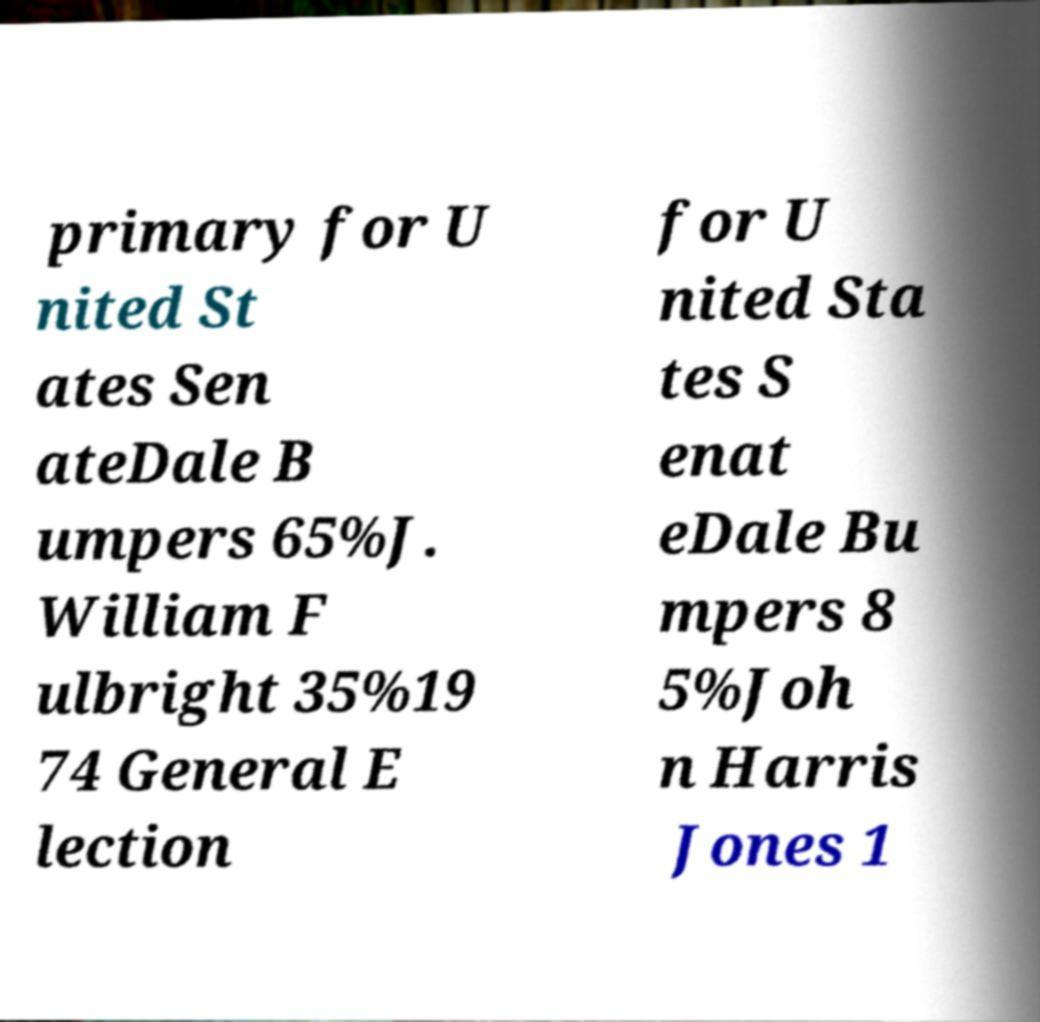Please identify and transcribe the text found in this image. primary for U nited St ates Sen ateDale B umpers 65%J. William F ulbright 35%19 74 General E lection for U nited Sta tes S enat eDale Bu mpers 8 5%Joh n Harris Jones 1 